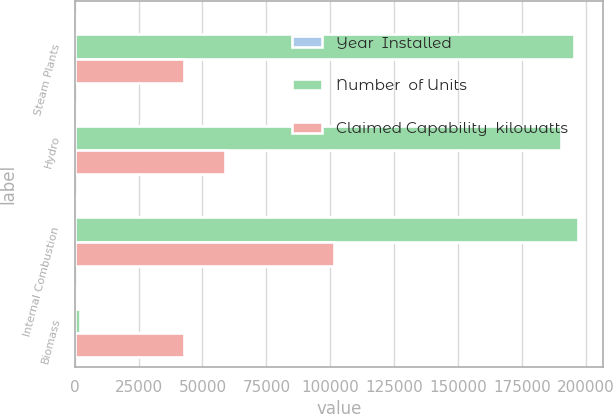<chart> <loc_0><loc_0><loc_500><loc_500><stacked_bar_chart><ecel><fcel>Steam Plants<fcel>Hydro<fcel>Internal Combustion<fcel>Biomass<nl><fcel>Year  Installed<fcel>5<fcel>20<fcel>5<fcel>1<nl><fcel>Number  of Units<fcel>195274<fcel>190183<fcel>196870<fcel>2006<nl><fcel>Claimed Capability  kilowatts<fcel>42594<fcel>58951<fcel>101535<fcel>42594<nl></chart> 